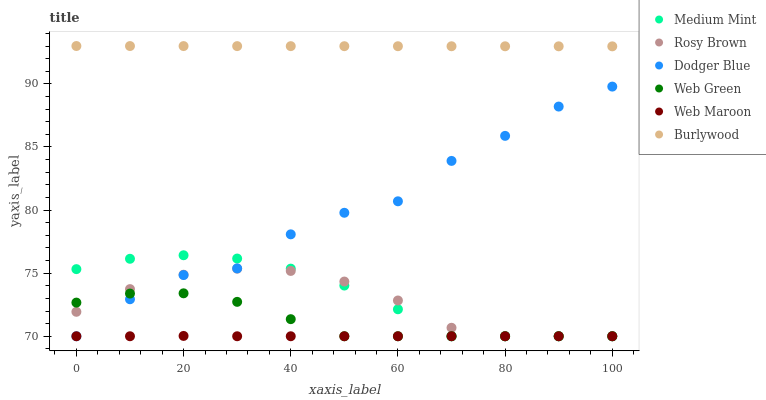Does Web Maroon have the minimum area under the curve?
Answer yes or no. Yes. Does Burlywood have the maximum area under the curve?
Answer yes or no. Yes. Does Rosy Brown have the minimum area under the curve?
Answer yes or no. No. Does Rosy Brown have the maximum area under the curve?
Answer yes or no. No. Is Burlywood the smoothest?
Answer yes or no. Yes. Is Dodger Blue the roughest?
Answer yes or no. Yes. Is Rosy Brown the smoothest?
Answer yes or no. No. Is Rosy Brown the roughest?
Answer yes or no. No. Does Medium Mint have the lowest value?
Answer yes or no. Yes. Does Burlywood have the lowest value?
Answer yes or no. No. Does Burlywood have the highest value?
Answer yes or no. Yes. Does Rosy Brown have the highest value?
Answer yes or no. No. Is Medium Mint less than Burlywood?
Answer yes or no. Yes. Is Burlywood greater than Rosy Brown?
Answer yes or no. Yes. Does Web Green intersect Medium Mint?
Answer yes or no. Yes. Is Web Green less than Medium Mint?
Answer yes or no. No. Is Web Green greater than Medium Mint?
Answer yes or no. No. Does Medium Mint intersect Burlywood?
Answer yes or no. No. 